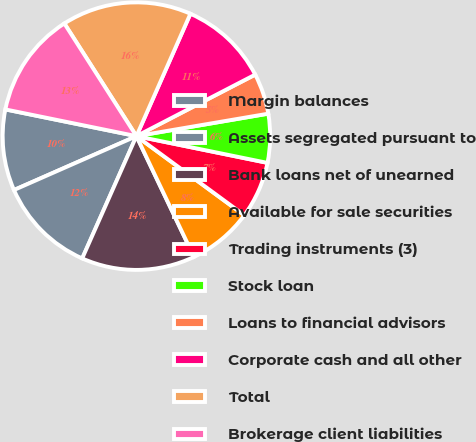Convert chart. <chart><loc_0><loc_0><loc_500><loc_500><pie_chart><fcel>Margin balances<fcel>Assets segregated pursuant to<fcel>Bank loans net of unearned<fcel>Available for sale securities<fcel>Trading instruments (3)<fcel>Stock loan<fcel>Loans to financial advisors<fcel>Corporate cash and all other<fcel>Total<fcel>Brokerage client liabilities<nl><fcel>9.8%<fcel>11.76%<fcel>13.72%<fcel>7.85%<fcel>6.87%<fcel>5.89%<fcel>4.92%<fcel>10.78%<fcel>15.67%<fcel>12.74%<nl></chart> 